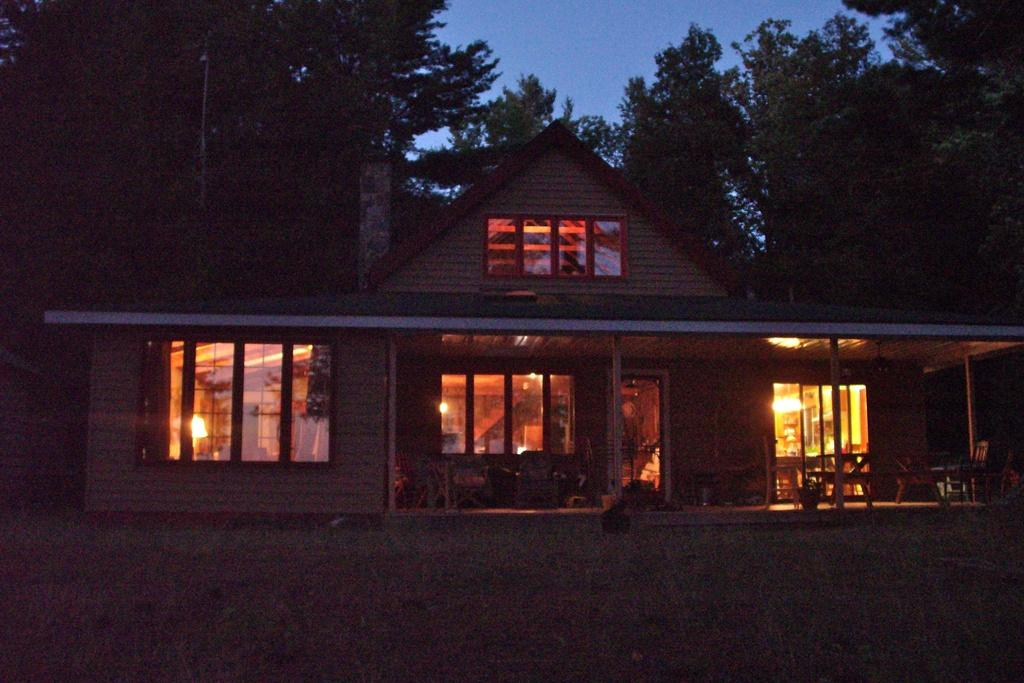What is the main subject in the center of the image? There is a house in the center of the image. What type of vegetation is present at the bottom of the image? There is grass at the bottom of the image. What can be seen in the background of the image? There are trees and the sky visible in the background of the image. What type of scarf is draped over the trees in the image? There is no scarf present in the image; it only features a house, grass, trees, and the sky. 